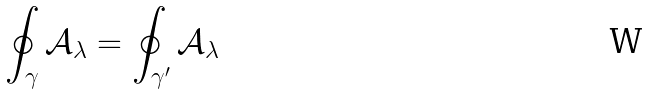Convert formula to latex. <formula><loc_0><loc_0><loc_500><loc_500>\oint \nolimits _ { \gamma } \mathcal { A } _ { \lambda } = \oint \nolimits _ { \gamma ^ { \prime } } \mathcal { A } _ { \lambda }</formula> 